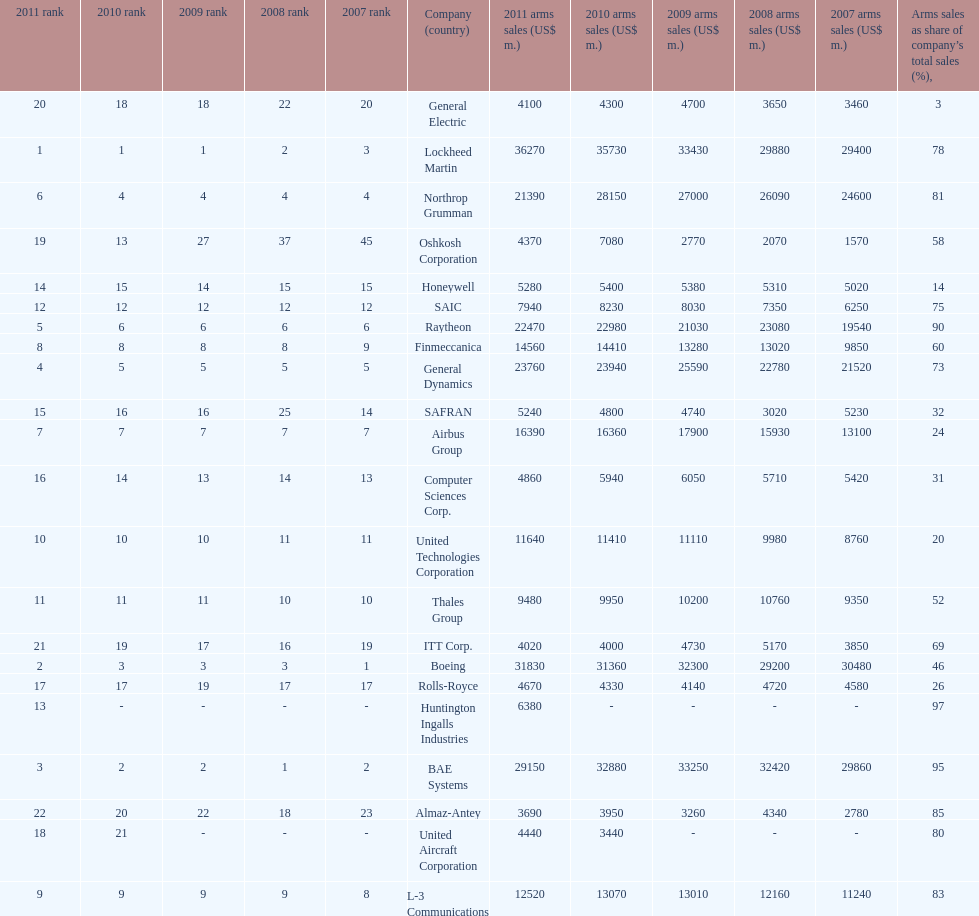In 2010, who recorded the lowest sales figures? United Aircraft Corporation. 